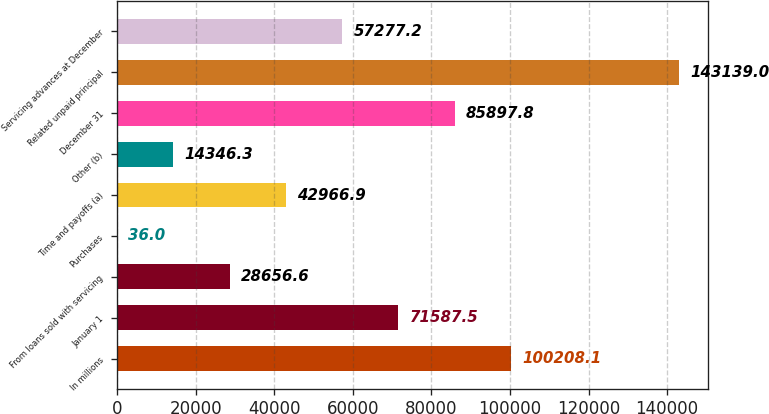<chart> <loc_0><loc_0><loc_500><loc_500><bar_chart><fcel>In millions<fcel>January 1<fcel>From loans sold with servicing<fcel>Purchases<fcel>Time and payoffs (a)<fcel>Other (b)<fcel>December 31<fcel>Related unpaid principal<fcel>Servicing advances at December<nl><fcel>100208<fcel>71587.5<fcel>28656.6<fcel>36<fcel>42966.9<fcel>14346.3<fcel>85897.8<fcel>143139<fcel>57277.2<nl></chart> 